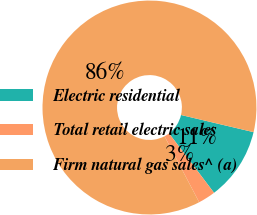<chart> <loc_0><loc_0><loc_500><loc_500><pie_chart><fcel>Electric residential<fcel>Total retail electric sales<fcel>Firm natural gas sales^ (a)<nl><fcel>10.99%<fcel>2.62%<fcel>86.39%<nl></chart> 